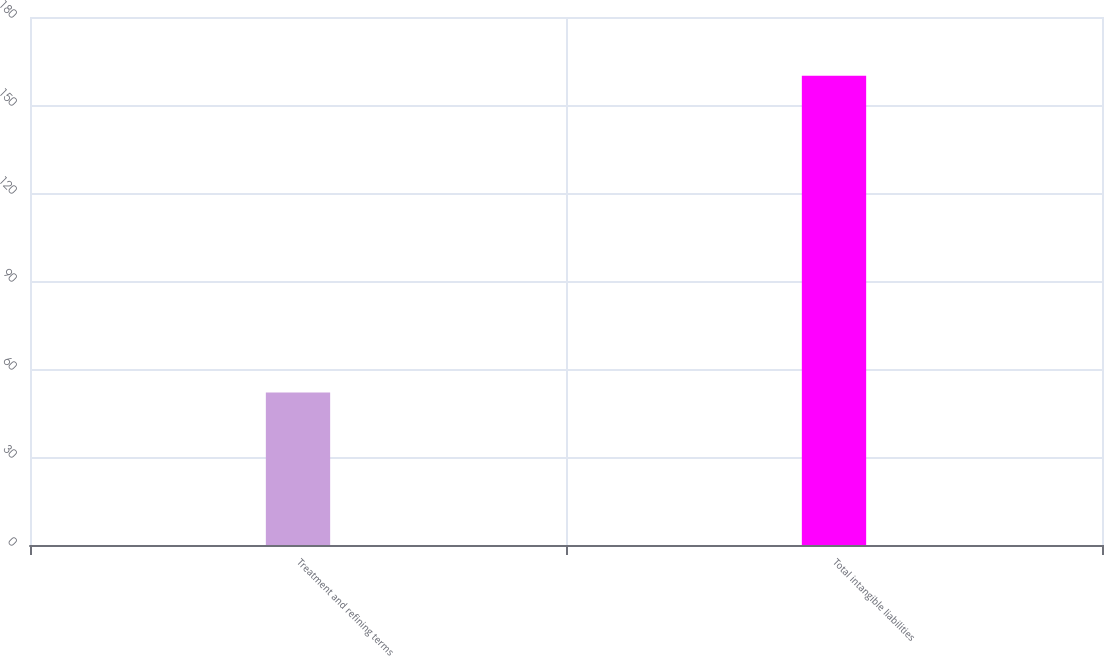Convert chart. <chart><loc_0><loc_0><loc_500><loc_500><bar_chart><fcel>Treatment and refining terms<fcel>Total intangible liabilities<nl><fcel>52<fcel>160<nl></chart> 